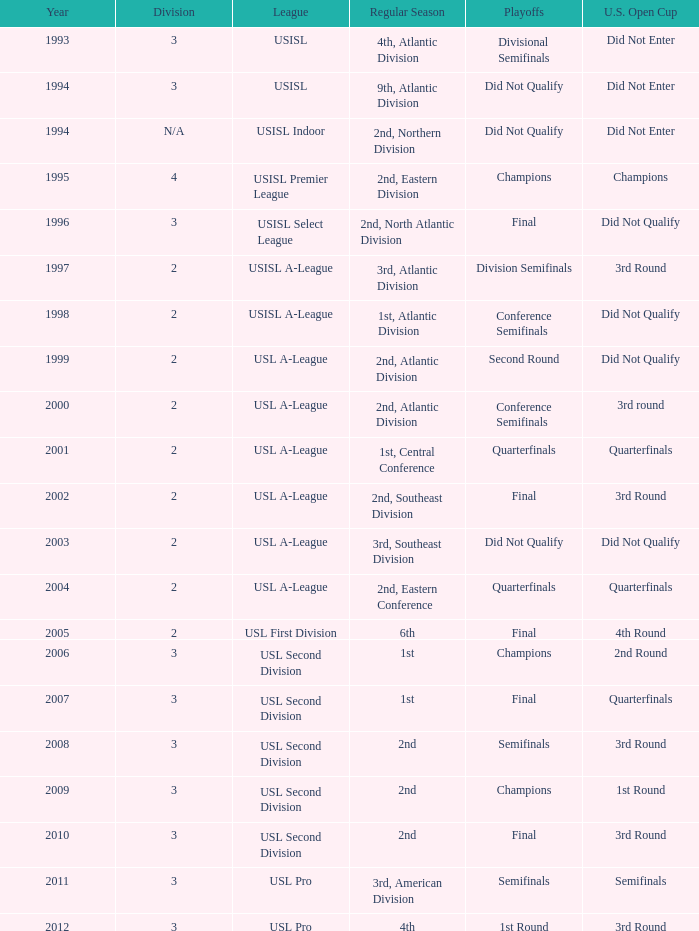Which round is u.s. open cup division semifinals 3rd Round. 